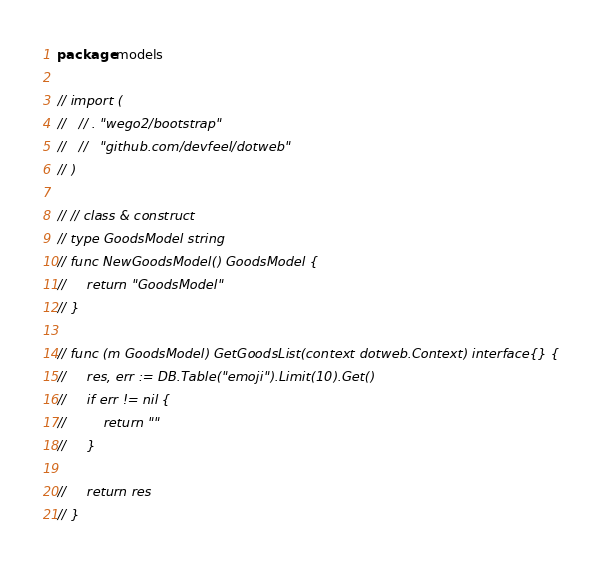Convert code to text. <code><loc_0><loc_0><loc_500><loc_500><_Go_>package models

// import (
//   // . "wego2/bootstrap"
//   //   "github.com/devfeel/dotweb"
// )

// // class & construct
// type GoodsModel string
// func NewGoodsModel() GoodsModel {
//     return "GoodsModel"
// }

// func (m GoodsModel) GetGoodsList(context dotweb.Context) interface{} {
//     res, err := DB.Table("emoji").Limit(10).Get()
//     if err != nil {
//         return ""
//     }

//     return res
// }
</code> 